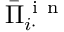Convert formula to latex. <formula><loc_0><loc_0><loc_500><loc_500>\bar { \Pi } _ { i \cdot } ^ { i n }</formula> 